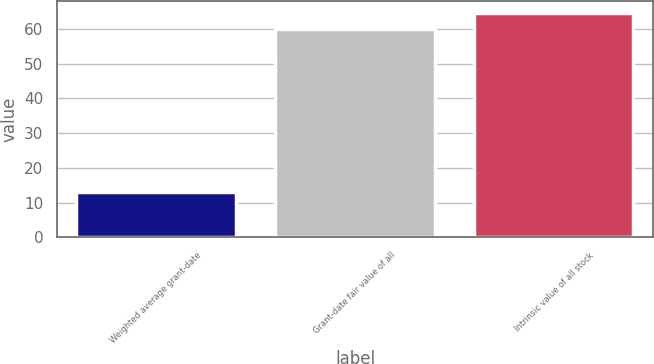<chart> <loc_0><loc_0><loc_500><loc_500><bar_chart><fcel>Weighted average grant-date<fcel>Grant-date fair value of all<fcel>Intrinsic value of all stock<nl><fcel>13.06<fcel>60<fcel>64.69<nl></chart> 